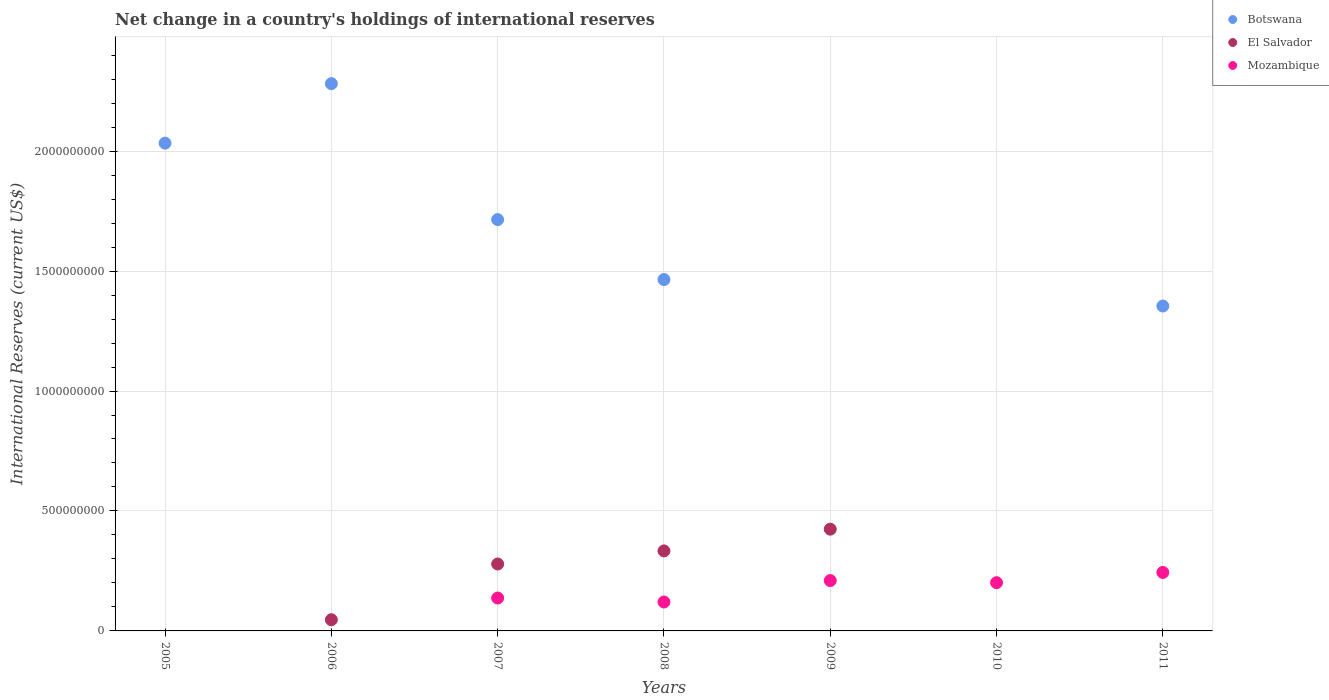How many different coloured dotlines are there?
Make the answer very short. 3. Is the number of dotlines equal to the number of legend labels?
Your answer should be very brief. No. What is the international reserves in Mozambique in 2008?
Make the answer very short. 1.21e+08. Across all years, what is the maximum international reserves in El Salvador?
Make the answer very short. 4.24e+08. In which year was the international reserves in Botswana maximum?
Ensure brevity in your answer.  2006. What is the total international reserves in Botswana in the graph?
Ensure brevity in your answer.  8.85e+09. What is the difference between the international reserves in Mozambique in 2008 and that in 2010?
Give a very brief answer. -8.05e+07. What is the difference between the international reserves in Mozambique in 2010 and the international reserves in Botswana in 2008?
Offer a terse response. -1.26e+09. What is the average international reserves in Botswana per year?
Give a very brief answer. 1.26e+09. In the year 2008, what is the difference between the international reserves in Mozambique and international reserves in Botswana?
Keep it short and to the point. -1.34e+09. What is the ratio of the international reserves in Botswana in 2008 to that in 2011?
Offer a terse response. 1.08. Is the international reserves in Mozambique in 2010 less than that in 2011?
Keep it short and to the point. Yes. What is the difference between the highest and the second highest international reserves in Botswana?
Give a very brief answer. 2.48e+08. What is the difference between the highest and the lowest international reserves in El Salvador?
Your answer should be very brief. 4.24e+08. Is the sum of the international reserves in Botswana in 2005 and 2007 greater than the maximum international reserves in El Salvador across all years?
Offer a terse response. Yes. Is it the case that in every year, the sum of the international reserves in El Salvador and international reserves in Mozambique  is greater than the international reserves in Botswana?
Offer a very short reply. No. Does the international reserves in Mozambique monotonically increase over the years?
Give a very brief answer. No. Is the international reserves in Mozambique strictly greater than the international reserves in Botswana over the years?
Keep it short and to the point. No. Is the international reserves in Mozambique strictly less than the international reserves in Botswana over the years?
Give a very brief answer. No. How many dotlines are there?
Make the answer very short. 3. How many years are there in the graph?
Offer a terse response. 7. What is the difference between two consecutive major ticks on the Y-axis?
Ensure brevity in your answer.  5.00e+08. Are the values on the major ticks of Y-axis written in scientific E-notation?
Your answer should be very brief. No. Does the graph contain any zero values?
Your response must be concise. Yes. Where does the legend appear in the graph?
Your answer should be compact. Top right. How are the legend labels stacked?
Provide a short and direct response. Vertical. What is the title of the graph?
Provide a short and direct response. Net change in a country's holdings of international reserves. Does "New Caledonia" appear as one of the legend labels in the graph?
Offer a very short reply. No. What is the label or title of the Y-axis?
Provide a short and direct response. International Reserves (current US$). What is the International Reserves (current US$) in Botswana in 2005?
Your answer should be compact. 2.03e+09. What is the International Reserves (current US$) in Botswana in 2006?
Your answer should be compact. 2.28e+09. What is the International Reserves (current US$) of El Salvador in 2006?
Your answer should be very brief. 4.66e+07. What is the International Reserves (current US$) of Mozambique in 2006?
Provide a succinct answer. 0. What is the International Reserves (current US$) in Botswana in 2007?
Provide a short and direct response. 1.71e+09. What is the International Reserves (current US$) in El Salvador in 2007?
Ensure brevity in your answer.  2.79e+08. What is the International Reserves (current US$) of Mozambique in 2007?
Keep it short and to the point. 1.37e+08. What is the International Reserves (current US$) of Botswana in 2008?
Offer a very short reply. 1.46e+09. What is the International Reserves (current US$) in El Salvador in 2008?
Your answer should be very brief. 3.33e+08. What is the International Reserves (current US$) in Mozambique in 2008?
Provide a succinct answer. 1.21e+08. What is the International Reserves (current US$) of El Salvador in 2009?
Offer a terse response. 4.24e+08. What is the International Reserves (current US$) in Mozambique in 2009?
Provide a succinct answer. 2.10e+08. What is the International Reserves (current US$) of Botswana in 2010?
Offer a very short reply. 0. What is the International Reserves (current US$) in El Salvador in 2010?
Your response must be concise. 0. What is the International Reserves (current US$) of Mozambique in 2010?
Your answer should be very brief. 2.01e+08. What is the International Reserves (current US$) in Botswana in 2011?
Your answer should be compact. 1.35e+09. What is the International Reserves (current US$) of Mozambique in 2011?
Offer a very short reply. 2.44e+08. Across all years, what is the maximum International Reserves (current US$) of Botswana?
Give a very brief answer. 2.28e+09. Across all years, what is the maximum International Reserves (current US$) of El Salvador?
Ensure brevity in your answer.  4.24e+08. Across all years, what is the maximum International Reserves (current US$) in Mozambique?
Give a very brief answer. 2.44e+08. Across all years, what is the minimum International Reserves (current US$) in Botswana?
Provide a short and direct response. 0. Across all years, what is the minimum International Reserves (current US$) of El Salvador?
Your answer should be compact. 0. What is the total International Reserves (current US$) of Botswana in the graph?
Provide a succinct answer. 8.85e+09. What is the total International Reserves (current US$) in El Salvador in the graph?
Make the answer very short. 1.08e+09. What is the total International Reserves (current US$) in Mozambique in the graph?
Give a very brief answer. 9.12e+08. What is the difference between the International Reserves (current US$) of Botswana in 2005 and that in 2006?
Your answer should be compact. -2.48e+08. What is the difference between the International Reserves (current US$) in Botswana in 2005 and that in 2007?
Offer a terse response. 3.19e+08. What is the difference between the International Reserves (current US$) of Botswana in 2005 and that in 2008?
Your answer should be very brief. 5.69e+08. What is the difference between the International Reserves (current US$) in Botswana in 2005 and that in 2011?
Make the answer very short. 6.79e+08. What is the difference between the International Reserves (current US$) in Botswana in 2006 and that in 2007?
Keep it short and to the point. 5.67e+08. What is the difference between the International Reserves (current US$) of El Salvador in 2006 and that in 2007?
Provide a short and direct response. -2.32e+08. What is the difference between the International Reserves (current US$) in Botswana in 2006 and that in 2008?
Offer a very short reply. 8.17e+08. What is the difference between the International Reserves (current US$) of El Salvador in 2006 and that in 2008?
Your response must be concise. -2.87e+08. What is the difference between the International Reserves (current US$) in El Salvador in 2006 and that in 2009?
Your response must be concise. -3.78e+08. What is the difference between the International Reserves (current US$) in Botswana in 2006 and that in 2011?
Keep it short and to the point. 9.27e+08. What is the difference between the International Reserves (current US$) of Botswana in 2007 and that in 2008?
Ensure brevity in your answer.  2.50e+08. What is the difference between the International Reserves (current US$) of El Salvador in 2007 and that in 2008?
Your answer should be compact. -5.45e+07. What is the difference between the International Reserves (current US$) in Mozambique in 2007 and that in 2008?
Offer a very short reply. 1.66e+07. What is the difference between the International Reserves (current US$) in El Salvador in 2007 and that in 2009?
Offer a terse response. -1.45e+08. What is the difference between the International Reserves (current US$) in Mozambique in 2007 and that in 2009?
Keep it short and to the point. -7.27e+07. What is the difference between the International Reserves (current US$) in Mozambique in 2007 and that in 2010?
Offer a very short reply. -6.39e+07. What is the difference between the International Reserves (current US$) in Botswana in 2007 and that in 2011?
Your answer should be compact. 3.60e+08. What is the difference between the International Reserves (current US$) in Mozambique in 2007 and that in 2011?
Offer a very short reply. -1.07e+08. What is the difference between the International Reserves (current US$) of El Salvador in 2008 and that in 2009?
Your answer should be very brief. -9.07e+07. What is the difference between the International Reserves (current US$) of Mozambique in 2008 and that in 2009?
Your answer should be compact. -8.92e+07. What is the difference between the International Reserves (current US$) in Mozambique in 2008 and that in 2010?
Provide a short and direct response. -8.05e+07. What is the difference between the International Reserves (current US$) of Botswana in 2008 and that in 2011?
Provide a short and direct response. 1.10e+08. What is the difference between the International Reserves (current US$) of Mozambique in 2008 and that in 2011?
Give a very brief answer. -1.23e+08. What is the difference between the International Reserves (current US$) of Mozambique in 2009 and that in 2010?
Your response must be concise. 8.73e+06. What is the difference between the International Reserves (current US$) in Mozambique in 2009 and that in 2011?
Offer a very short reply. -3.39e+07. What is the difference between the International Reserves (current US$) of Mozambique in 2010 and that in 2011?
Offer a very short reply. -4.26e+07. What is the difference between the International Reserves (current US$) of Botswana in 2005 and the International Reserves (current US$) of El Salvador in 2006?
Your answer should be compact. 1.99e+09. What is the difference between the International Reserves (current US$) of Botswana in 2005 and the International Reserves (current US$) of El Salvador in 2007?
Make the answer very short. 1.75e+09. What is the difference between the International Reserves (current US$) in Botswana in 2005 and the International Reserves (current US$) in Mozambique in 2007?
Your answer should be compact. 1.90e+09. What is the difference between the International Reserves (current US$) of Botswana in 2005 and the International Reserves (current US$) of El Salvador in 2008?
Offer a terse response. 1.70e+09. What is the difference between the International Reserves (current US$) in Botswana in 2005 and the International Reserves (current US$) in Mozambique in 2008?
Give a very brief answer. 1.91e+09. What is the difference between the International Reserves (current US$) of Botswana in 2005 and the International Reserves (current US$) of El Salvador in 2009?
Provide a short and direct response. 1.61e+09. What is the difference between the International Reserves (current US$) of Botswana in 2005 and the International Reserves (current US$) of Mozambique in 2009?
Provide a short and direct response. 1.82e+09. What is the difference between the International Reserves (current US$) in Botswana in 2005 and the International Reserves (current US$) in Mozambique in 2010?
Your response must be concise. 1.83e+09. What is the difference between the International Reserves (current US$) of Botswana in 2005 and the International Reserves (current US$) of Mozambique in 2011?
Offer a terse response. 1.79e+09. What is the difference between the International Reserves (current US$) in Botswana in 2006 and the International Reserves (current US$) in El Salvador in 2007?
Keep it short and to the point. 2.00e+09. What is the difference between the International Reserves (current US$) of Botswana in 2006 and the International Reserves (current US$) of Mozambique in 2007?
Offer a terse response. 2.14e+09. What is the difference between the International Reserves (current US$) in El Salvador in 2006 and the International Reserves (current US$) in Mozambique in 2007?
Provide a succinct answer. -9.05e+07. What is the difference between the International Reserves (current US$) of Botswana in 2006 and the International Reserves (current US$) of El Salvador in 2008?
Your answer should be very brief. 1.95e+09. What is the difference between the International Reserves (current US$) in Botswana in 2006 and the International Reserves (current US$) in Mozambique in 2008?
Ensure brevity in your answer.  2.16e+09. What is the difference between the International Reserves (current US$) in El Salvador in 2006 and the International Reserves (current US$) in Mozambique in 2008?
Provide a succinct answer. -7.39e+07. What is the difference between the International Reserves (current US$) of Botswana in 2006 and the International Reserves (current US$) of El Salvador in 2009?
Offer a very short reply. 1.86e+09. What is the difference between the International Reserves (current US$) in Botswana in 2006 and the International Reserves (current US$) in Mozambique in 2009?
Offer a very short reply. 2.07e+09. What is the difference between the International Reserves (current US$) in El Salvador in 2006 and the International Reserves (current US$) in Mozambique in 2009?
Provide a succinct answer. -1.63e+08. What is the difference between the International Reserves (current US$) of Botswana in 2006 and the International Reserves (current US$) of Mozambique in 2010?
Offer a very short reply. 2.08e+09. What is the difference between the International Reserves (current US$) in El Salvador in 2006 and the International Reserves (current US$) in Mozambique in 2010?
Provide a short and direct response. -1.54e+08. What is the difference between the International Reserves (current US$) of Botswana in 2006 and the International Reserves (current US$) of Mozambique in 2011?
Make the answer very short. 2.04e+09. What is the difference between the International Reserves (current US$) in El Salvador in 2006 and the International Reserves (current US$) in Mozambique in 2011?
Keep it short and to the point. -1.97e+08. What is the difference between the International Reserves (current US$) of Botswana in 2007 and the International Reserves (current US$) of El Salvador in 2008?
Your answer should be very brief. 1.38e+09. What is the difference between the International Reserves (current US$) in Botswana in 2007 and the International Reserves (current US$) in Mozambique in 2008?
Your answer should be compact. 1.59e+09. What is the difference between the International Reserves (current US$) of El Salvador in 2007 and the International Reserves (current US$) of Mozambique in 2008?
Your answer should be compact. 1.58e+08. What is the difference between the International Reserves (current US$) of Botswana in 2007 and the International Reserves (current US$) of El Salvador in 2009?
Your answer should be compact. 1.29e+09. What is the difference between the International Reserves (current US$) of Botswana in 2007 and the International Reserves (current US$) of Mozambique in 2009?
Provide a short and direct response. 1.50e+09. What is the difference between the International Reserves (current US$) of El Salvador in 2007 and the International Reserves (current US$) of Mozambique in 2009?
Ensure brevity in your answer.  6.92e+07. What is the difference between the International Reserves (current US$) in Botswana in 2007 and the International Reserves (current US$) in Mozambique in 2010?
Provide a short and direct response. 1.51e+09. What is the difference between the International Reserves (current US$) in El Salvador in 2007 and the International Reserves (current US$) in Mozambique in 2010?
Give a very brief answer. 7.79e+07. What is the difference between the International Reserves (current US$) in Botswana in 2007 and the International Reserves (current US$) in Mozambique in 2011?
Your answer should be very brief. 1.47e+09. What is the difference between the International Reserves (current US$) in El Salvador in 2007 and the International Reserves (current US$) in Mozambique in 2011?
Provide a short and direct response. 3.53e+07. What is the difference between the International Reserves (current US$) in Botswana in 2008 and the International Reserves (current US$) in El Salvador in 2009?
Offer a terse response. 1.04e+09. What is the difference between the International Reserves (current US$) of Botswana in 2008 and the International Reserves (current US$) of Mozambique in 2009?
Give a very brief answer. 1.25e+09. What is the difference between the International Reserves (current US$) of El Salvador in 2008 and the International Reserves (current US$) of Mozambique in 2009?
Provide a short and direct response. 1.24e+08. What is the difference between the International Reserves (current US$) in Botswana in 2008 and the International Reserves (current US$) in Mozambique in 2010?
Offer a terse response. 1.26e+09. What is the difference between the International Reserves (current US$) in El Salvador in 2008 and the International Reserves (current US$) in Mozambique in 2010?
Your answer should be very brief. 1.32e+08. What is the difference between the International Reserves (current US$) of Botswana in 2008 and the International Reserves (current US$) of Mozambique in 2011?
Provide a succinct answer. 1.22e+09. What is the difference between the International Reserves (current US$) in El Salvador in 2008 and the International Reserves (current US$) in Mozambique in 2011?
Your answer should be compact. 8.98e+07. What is the difference between the International Reserves (current US$) of El Salvador in 2009 and the International Reserves (current US$) of Mozambique in 2010?
Provide a succinct answer. 2.23e+08. What is the difference between the International Reserves (current US$) in El Salvador in 2009 and the International Reserves (current US$) in Mozambique in 2011?
Offer a terse response. 1.81e+08. What is the average International Reserves (current US$) of Botswana per year?
Offer a terse response. 1.26e+09. What is the average International Reserves (current US$) of El Salvador per year?
Provide a short and direct response. 1.55e+08. What is the average International Reserves (current US$) of Mozambique per year?
Give a very brief answer. 1.30e+08. In the year 2006, what is the difference between the International Reserves (current US$) in Botswana and International Reserves (current US$) in El Salvador?
Make the answer very short. 2.23e+09. In the year 2007, what is the difference between the International Reserves (current US$) in Botswana and International Reserves (current US$) in El Salvador?
Provide a succinct answer. 1.44e+09. In the year 2007, what is the difference between the International Reserves (current US$) in Botswana and International Reserves (current US$) in Mozambique?
Offer a very short reply. 1.58e+09. In the year 2007, what is the difference between the International Reserves (current US$) in El Salvador and International Reserves (current US$) in Mozambique?
Your answer should be very brief. 1.42e+08. In the year 2008, what is the difference between the International Reserves (current US$) in Botswana and International Reserves (current US$) in El Salvador?
Your response must be concise. 1.13e+09. In the year 2008, what is the difference between the International Reserves (current US$) of Botswana and International Reserves (current US$) of Mozambique?
Your response must be concise. 1.34e+09. In the year 2008, what is the difference between the International Reserves (current US$) in El Salvador and International Reserves (current US$) in Mozambique?
Ensure brevity in your answer.  2.13e+08. In the year 2009, what is the difference between the International Reserves (current US$) in El Salvador and International Reserves (current US$) in Mozambique?
Make the answer very short. 2.14e+08. In the year 2011, what is the difference between the International Reserves (current US$) of Botswana and International Reserves (current US$) of Mozambique?
Your answer should be compact. 1.11e+09. What is the ratio of the International Reserves (current US$) in Botswana in 2005 to that in 2006?
Offer a terse response. 0.89. What is the ratio of the International Reserves (current US$) of Botswana in 2005 to that in 2007?
Make the answer very short. 1.19. What is the ratio of the International Reserves (current US$) of Botswana in 2005 to that in 2008?
Ensure brevity in your answer.  1.39. What is the ratio of the International Reserves (current US$) in Botswana in 2005 to that in 2011?
Keep it short and to the point. 1.5. What is the ratio of the International Reserves (current US$) in Botswana in 2006 to that in 2007?
Make the answer very short. 1.33. What is the ratio of the International Reserves (current US$) in El Salvador in 2006 to that in 2007?
Your answer should be very brief. 0.17. What is the ratio of the International Reserves (current US$) of Botswana in 2006 to that in 2008?
Provide a short and direct response. 1.56. What is the ratio of the International Reserves (current US$) of El Salvador in 2006 to that in 2008?
Offer a terse response. 0.14. What is the ratio of the International Reserves (current US$) in El Salvador in 2006 to that in 2009?
Provide a short and direct response. 0.11. What is the ratio of the International Reserves (current US$) of Botswana in 2006 to that in 2011?
Your answer should be very brief. 1.68. What is the ratio of the International Reserves (current US$) of Botswana in 2007 to that in 2008?
Offer a very short reply. 1.17. What is the ratio of the International Reserves (current US$) of El Salvador in 2007 to that in 2008?
Your answer should be very brief. 0.84. What is the ratio of the International Reserves (current US$) of Mozambique in 2007 to that in 2008?
Your answer should be very brief. 1.14. What is the ratio of the International Reserves (current US$) in El Salvador in 2007 to that in 2009?
Give a very brief answer. 0.66. What is the ratio of the International Reserves (current US$) of Mozambique in 2007 to that in 2009?
Ensure brevity in your answer.  0.65. What is the ratio of the International Reserves (current US$) of Mozambique in 2007 to that in 2010?
Give a very brief answer. 0.68. What is the ratio of the International Reserves (current US$) of Botswana in 2007 to that in 2011?
Give a very brief answer. 1.27. What is the ratio of the International Reserves (current US$) of Mozambique in 2007 to that in 2011?
Ensure brevity in your answer.  0.56. What is the ratio of the International Reserves (current US$) of El Salvador in 2008 to that in 2009?
Ensure brevity in your answer.  0.79. What is the ratio of the International Reserves (current US$) in Mozambique in 2008 to that in 2009?
Make the answer very short. 0.57. What is the ratio of the International Reserves (current US$) in Mozambique in 2008 to that in 2010?
Keep it short and to the point. 0.6. What is the ratio of the International Reserves (current US$) of Botswana in 2008 to that in 2011?
Your response must be concise. 1.08. What is the ratio of the International Reserves (current US$) in Mozambique in 2008 to that in 2011?
Provide a short and direct response. 0.49. What is the ratio of the International Reserves (current US$) of Mozambique in 2009 to that in 2010?
Make the answer very short. 1.04. What is the ratio of the International Reserves (current US$) in Mozambique in 2009 to that in 2011?
Give a very brief answer. 0.86. What is the ratio of the International Reserves (current US$) of Mozambique in 2010 to that in 2011?
Ensure brevity in your answer.  0.83. What is the difference between the highest and the second highest International Reserves (current US$) of Botswana?
Offer a terse response. 2.48e+08. What is the difference between the highest and the second highest International Reserves (current US$) in El Salvador?
Make the answer very short. 9.07e+07. What is the difference between the highest and the second highest International Reserves (current US$) of Mozambique?
Your answer should be compact. 3.39e+07. What is the difference between the highest and the lowest International Reserves (current US$) of Botswana?
Make the answer very short. 2.28e+09. What is the difference between the highest and the lowest International Reserves (current US$) of El Salvador?
Make the answer very short. 4.24e+08. What is the difference between the highest and the lowest International Reserves (current US$) in Mozambique?
Provide a succinct answer. 2.44e+08. 